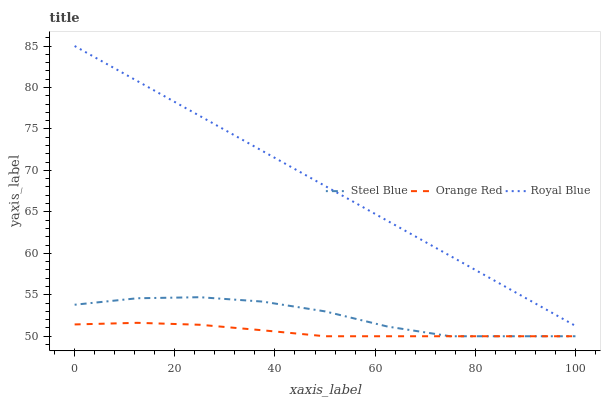Does Orange Red have the minimum area under the curve?
Answer yes or no. Yes. Does Royal Blue have the maximum area under the curve?
Answer yes or no. Yes. Does Steel Blue have the minimum area under the curve?
Answer yes or no. No. Does Steel Blue have the maximum area under the curve?
Answer yes or no. No. Is Royal Blue the smoothest?
Answer yes or no. Yes. Is Steel Blue the roughest?
Answer yes or no. Yes. Is Orange Red the smoothest?
Answer yes or no. No. Is Orange Red the roughest?
Answer yes or no. No. Does Royal Blue have the highest value?
Answer yes or no. Yes. Does Steel Blue have the highest value?
Answer yes or no. No. Is Orange Red less than Royal Blue?
Answer yes or no. Yes. Is Royal Blue greater than Steel Blue?
Answer yes or no. Yes. Does Orange Red intersect Steel Blue?
Answer yes or no. Yes. Is Orange Red less than Steel Blue?
Answer yes or no. No. Is Orange Red greater than Steel Blue?
Answer yes or no. No. Does Orange Red intersect Royal Blue?
Answer yes or no. No. 